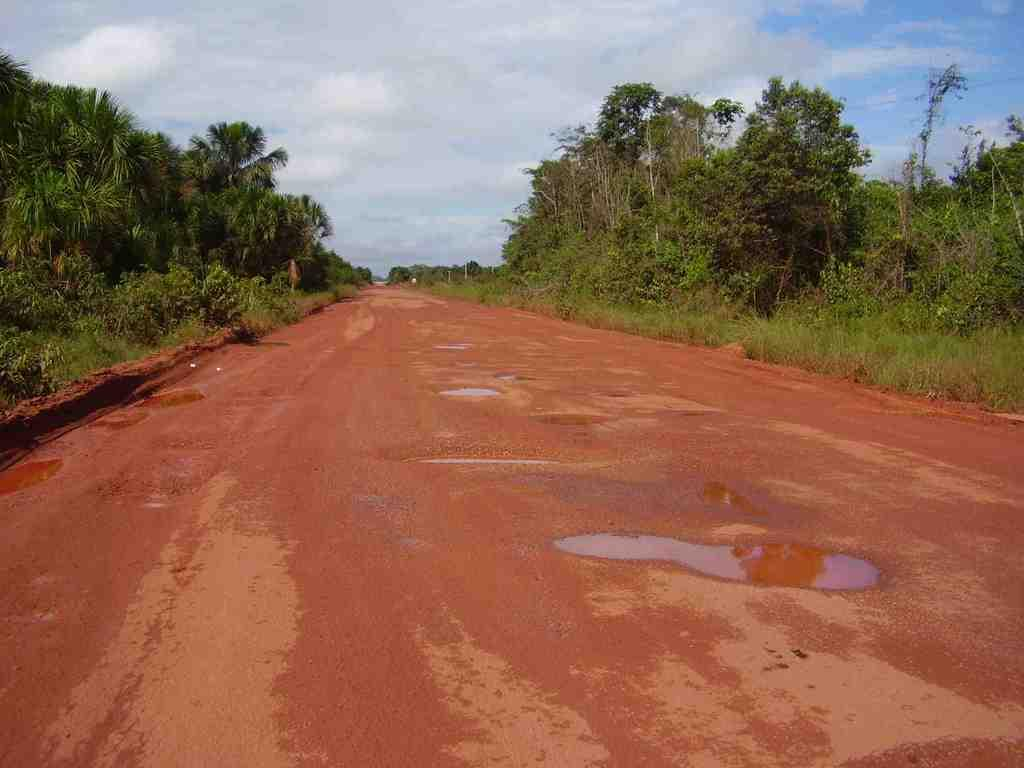What type of imperfections can be seen in the image? There are potholes in the image. What type of vegetation is present in the image? There are plants and trees in the image. What is visible in the background of the image? The sky is visible in the background of the image. Can you see any quince trees in the image? There is no mention of quince trees in the provided facts, and therefore we cannot determine if they are present in the image. Is there a matchstick visible in the image? There is no mention of a matchstick in the provided facts, and therefore we cannot determine if it is present in the image. 